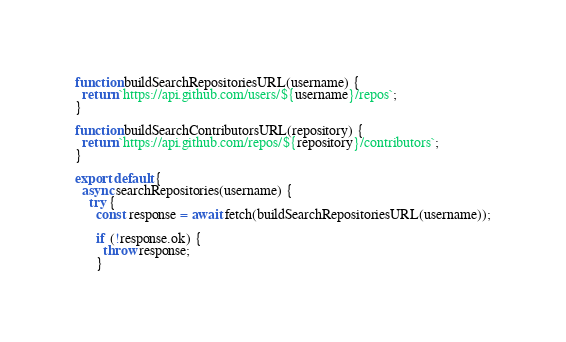Convert code to text. <code><loc_0><loc_0><loc_500><loc_500><_JavaScript_>function buildSearchRepositoriesURL(username) {
  return `https://api.github.com/users/${username}/repos`;
}

function buildSearchContributorsURL(repository) {
  return `https://api.github.com/repos/${repository}/contributors`;
}

export default {
  async searchRepositories(username) {
    try {
      const response = await fetch(buildSearchRepositoriesURL(username));

      if (!response.ok) {
        throw response;
      }
</code> 